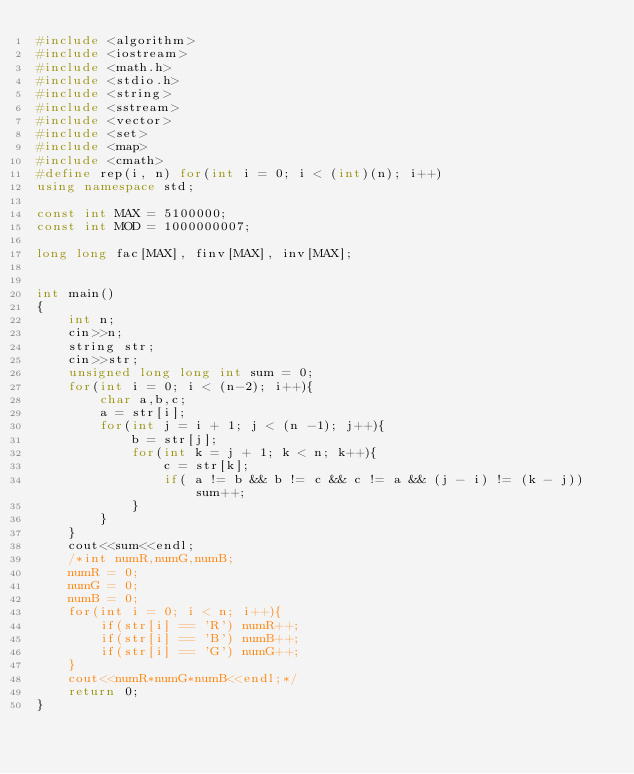Convert code to text. <code><loc_0><loc_0><loc_500><loc_500><_C++_>#include <algorithm>
#include <iostream>
#include <math.h>
#include <stdio.h>
#include <string>
#include <sstream>
#include <vector>
#include <set>
#include <map>
#include <cmath>
#define rep(i, n) for(int i = 0; i < (int)(n); i++)
using namespace std;

const int MAX = 5100000;
const int MOD = 1000000007;

long long fac[MAX], finv[MAX], inv[MAX];


int main()
{
	int n;
	cin>>n;
	string str;
	cin>>str;
	unsigned long long int sum = 0;
	for(int i = 0; i < (n-2); i++){
		char a,b,c;
		a = str[i];
		for(int j = i + 1; j < (n -1); j++){
			b = str[j];
			for(int k = j + 1; k < n; k++){
				c = str[k];
				if( a != b && b != c && c != a && (j - i) != (k - j)) sum++;
			}
		}
	}
	cout<<sum<<endl;
	/*int numR,numG,numB;
	numR = 0;
	numG = 0;
	numB = 0;
	for(int i = 0; i < n; i++){
		if(str[i] == 'R') numR++;
		if(str[i] == 'B') numB++;
		if(str[i] == 'G') numG++;
	}
	cout<<numR*numG*numB<<endl;*/
	return 0;
}

</code> 